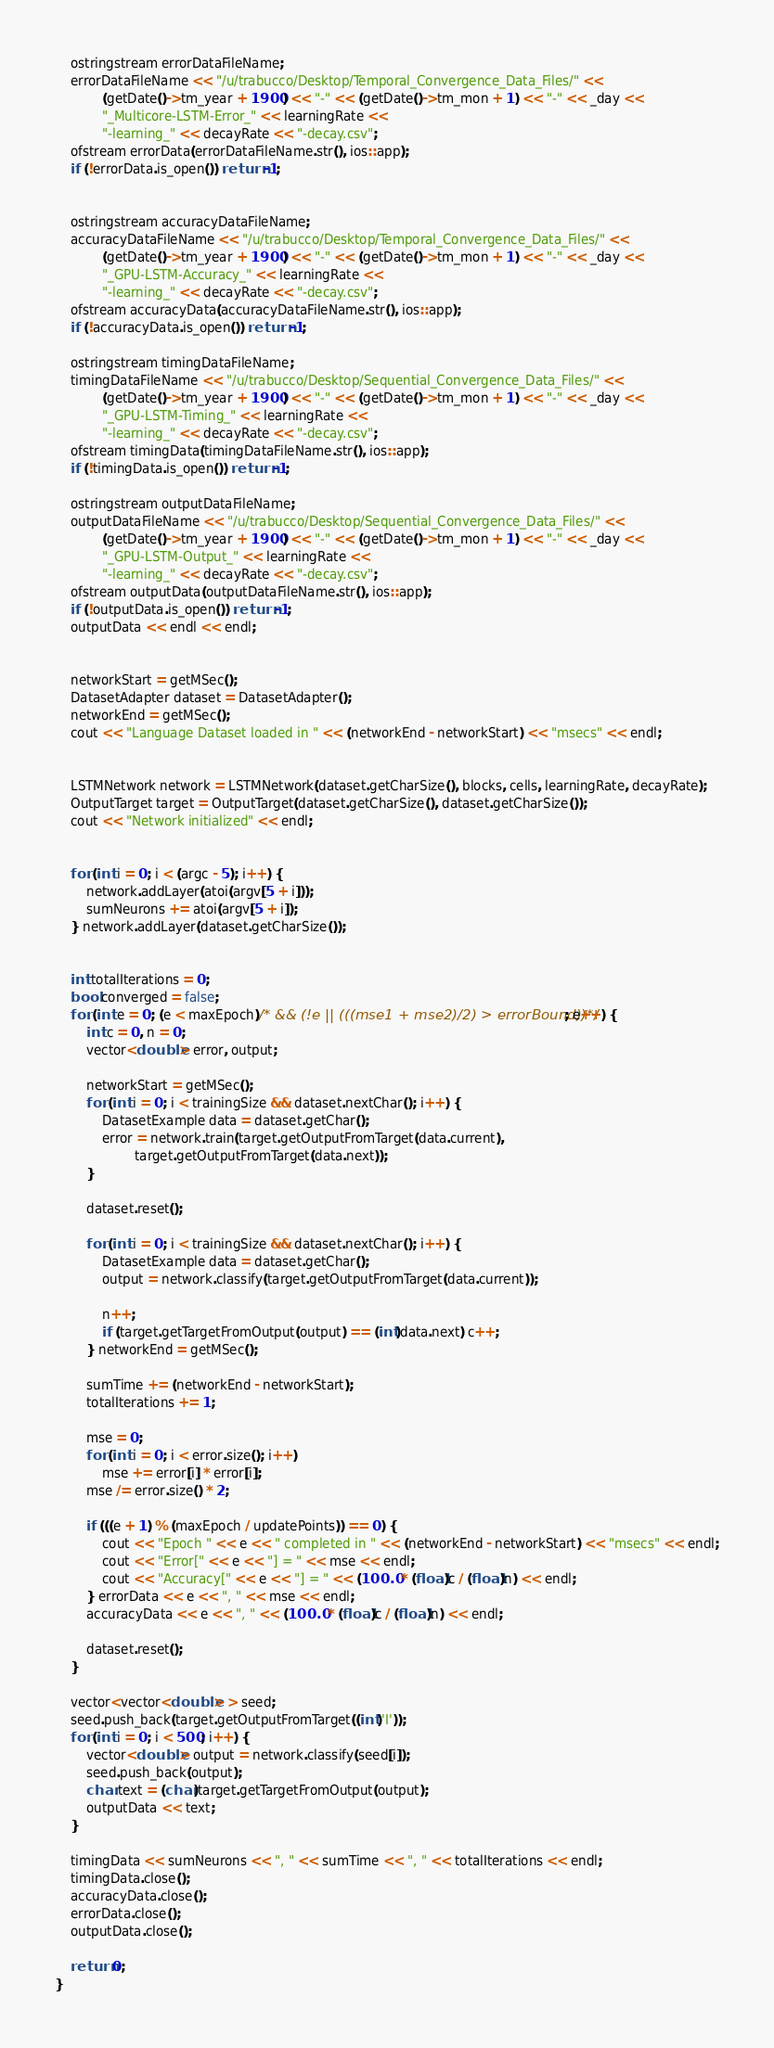Convert code to text. <code><loc_0><loc_0><loc_500><loc_500><_Cuda_>	ostringstream errorDataFileName;
	errorDataFileName << "/u/trabucco/Desktop/Temporal_Convergence_Data_Files/" <<
			(getDate()->tm_year + 1900) << "-" << (getDate()->tm_mon + 1) << "-" << _day <<
			"_Multicore-LSTM-Error_" << learningRate <<
			"-learning_" << decayRate << "-decay.csv";
	ofstream errorData(errorDataFileName.str(), ios::app);
	if (!errorData.is_open()) return -1;


	ostringstream accuracyDataFileName;
	accuracyDataFileName << "/u/trabucco/Desktop/Temporal_Convergence_Data_Files/" <<
			(getDate()->tm_year + 1900) << "-" << (getDate()->tm_mon + 1) << "-" << _day <<
			"_GPU-LSTM-Accuracy_" << learningRate <<
			"-learning_" << decayRate << "-decay.csv";
	ofstream accuracyData(accuracyDataFileName.str(), ios::app);
	if (!accuracyData.is_open()) return -1;

	ostringstream timingDataFileName;
	timingDataFileName << "/u/trabucco/Desktop/Sequential_Convergence_Data_Files/" <<
			(getDate()->tm_year + 1900) << "-" << (getDate()->tm_mon + 1) << "-" << _day <<
			"_GPU-LSTM-Timing_" << learningRate <<
			"-learning_" << decayRate << "-decay.csv";
	ofstream timingData(timingDataFileName.str(), ios::app);
	if (!timingData.is_open()) return -1;

	ostringstream outputDataFileName;
	outputDataFileName << "/u/trabucco/Desktop/Sequential_Convergence_Data_Files/" <<
			(getDate()->tm_year + 1900) << "-" << (getDate()->tm_mon + 1) << "-" << _day <<
			"_GPU-LSTM-Output_" << learningRate <<
			"-learning_" << decayRate << "-decay.csv";
	ofstream outputData(outputDataFileName.str(), ios::app);
	if (!outputData.is_open()) return -1;
	outputData << endl << endl;


	networkStart = getMSec();
	DatasetAdapter dataset = DatasetAdapter();
	networkEnd = getMSec();
	cout << "Language Dataset loaded in " << (networkEnd - networkStart) << "msecs" << endl;


	LSTMNetwork network = LSTMNetwork(dataset.getCharSize(), blocks, cells, learningRate, decayRate);
	OutputTarget target = OutputTarget(dataset.getCharSize(), dataset.getCharSize());
	cout << "Network initialized" << endl;


	for (int i = 0; i < (argc - 5); i++) {
		network.addLayer(atoi(argv[5 + i]));
		sumNeurons += atoi(argv[5 + i]);
	} network.addLayer(dataset.getCharSize());


	int totalIterations = 0;
	bool converged = false;
	for (int e = 0; (e < maxEpoch)/* && (!e || (((mse1 + mse2)/2) > errorBound))*/; e++) {
		int c = 0, n = 0;
		vector<double> error, output;

		networkStart = getMSec();
		for (int i = 0; i < trainingSize && dataset.nextChar(); i++) {
			DatasetExample data = dataset.getChar();
			error = network.train(target.getOutputFromTarget(data.current),
					target.getOutputFromTarget(data.next));
		}

		dataset.reset();

		for (int i = 0; i < trainingSize && dataset.nextChar(); i++) {
			DatasetExample data = dataset.getChar();
			output = network.classify(target.getOutputFromTarget(data.current));

			n++;
			if (target.getTargetFromOutput(output) == (int)data.next) c++;
		} networkEnd = getMSec();

		sumTime += (networkEnd - networkStart);
		totalIterations += 1;

		mse = 0;
		for (int i = 0; i < error.size(); i++)
			mse += error[i] * error[i];
		mse /= error.size() * 2;

		if (((e + 1) % (maxEpoch / updatePoints)) == 0) {
			cout << "Epoch " << e << " completed in " << (networkEnd - networkStart) << "msecs" << endl;
			cout << "Error[" << e << "] = " << mse << endl;
			cout << "Accuracy[" << e << "] = " << (100.0 * (float)c / (float)n) << endl;
		} errorData << e << ", " << mse << endl;
		accuracyData << e << ", " << (100.0 * (float)c / (float)n) << endl;

		dataset.reset();
	}

	vector<vector<double> > seed;
	seed.push_back(target.getOutputFromTarget((int)'I'));
	for (int i = 0; i < 500; i++) {
		vector<double> output = network.classify(seed[i]);
		seed.push_back(output);
		char text = (char)target.getTargetFromOutput(output);
		outputData << text;
	}

	timingData << sumNeurons << ", " << sumTime << ", " << totalIterations << endl;
	timingData.close();
	accuracyData.close();
	errorData.close();
	outputData.close();

	return 0;
}
</code> 